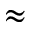Convert formula to latex. <formula><loc_0><loc_0><loc_500><loc_500>\approx</formula> 